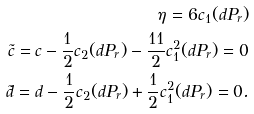Convert formula to latex. <formula><loc_0><loc_0><loc_500><loc_500>\eta = 6 c _ { 1 } ( d P _ { r } ) \\ \tilde { c } = c - \frac { 1 } { 2 } c _ { 2 } ( d P _ { r } ) - \frac { 1 1 } { 2 } c ^ { 2 } _ { 1 } ( d P _ { r } ) = 0 \\ \tilde { d } = d - \frac { 1 } { 2 } c _ { 2 } ( d P _ { r } ) + \frac { 1 } { 2 } c ^ { 2 } _ { 1 } ( d P _ { r } ) = 0 .</formula> 